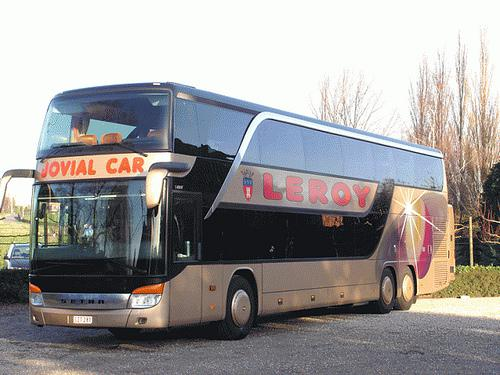Question: what does the bus say?
Choices:
A. Joe.
B. Frank.
C. Louis.
D. "Leroy.".
Answer with the letter. Answer: D Question: what is in the photo?
Choices:
A. A bus.
B. Train.
C. Taxi.
D. Airplane.
Answer with the letter. Answer: A Question: what color is the bus?
Choices:
A. Yellow.
B. Red.
C. Brown and black.
D. White.
Answer with the letter. Answer: C Question: how does the bus look?
Choices:
A. New.
B. Old.
C. Beat up.
D. Shiny.
Answer with the letter. Answer: A Question: why is the bus parked there?
Choices:
A. It's a bus stop.
B. There is no garage.
C. People are boarding.
D. No where else to park.
Answer with the letter. Answer: B Question: where was the photo taken?
Choices:
A. Cleveland.
B. Chicago.
C. Baltimore.
D. Charlotte.
Answer with the letter. Answer: A 